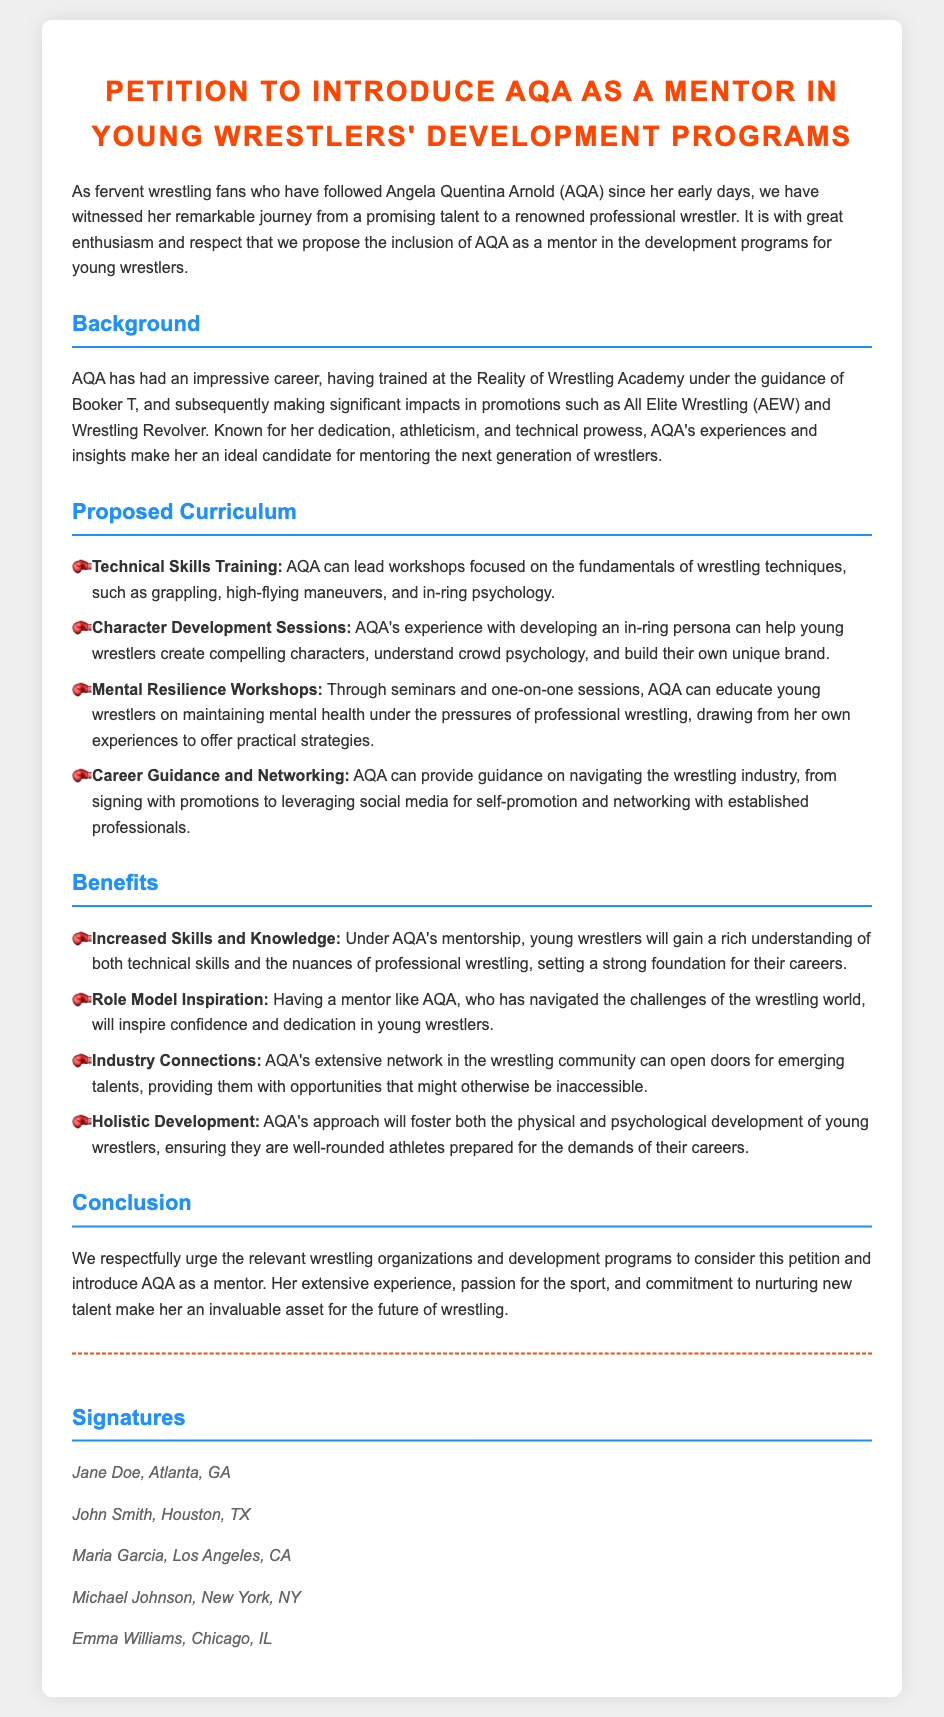What is the main purpose of this petition? The petition aims to introduce AQA as a mentor in young wrestlers' development programs.
Answer: To introduce AQA as a mentor What is AQA's full name? The document refers to her as Angela Quentina Arnold.
Answer: Angela Quentina Arnold Who trained AQA in the early part of her career? The document states that she trained at the Reality of Wrestling Academy under Booker T.
Answer: Booker T What is one of the proposed technical skills AQA will teach? One proposed skill is grappling according to the curriculum outlined in the petition.
Answer: Grappling How many benefits are listed in the petition? The document outlines four distinct benefits of introducing AQA as a mentor.
Answer: Four What type of workshops will focus on mental health? The document mentions Mental Resilience Workshops as the sessions dedicated to mental health.
Answer: Mental Resilience Workshops What city is Jane Doe from? Jane Doe is identified as being from Atlanta, Georgia in the list of signatures.
Answer: Atlanta, GA What does AQA's curriculum include apart from technical skills? Apart from technical skills, it includes Character Development Sessions and Career Guidance.
Answer: Character Development Sessions What is the final section of the document titled? The final section of the document is titled "Conclusion."
Answer: Conclusion 